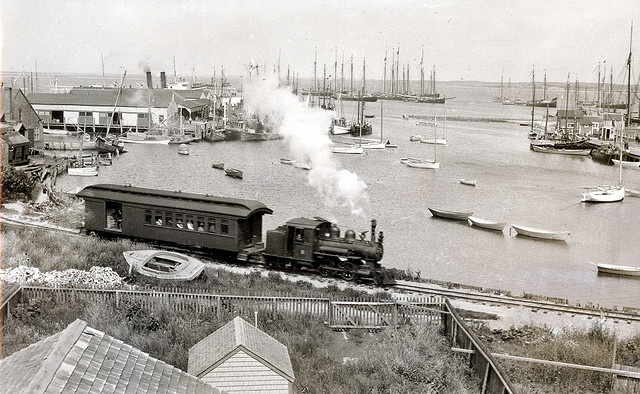Describe the objects in this image and their specific colors. I can see train in white, black, gray, and darkgray tones, boat in white, darkgray, lightgray, gray, and black tones, boat in white, darkgray, and black tones, boat in white, lightgray, darkgray, and gray tones, and boat in white, lightgray, and darkgray tones in this image. 